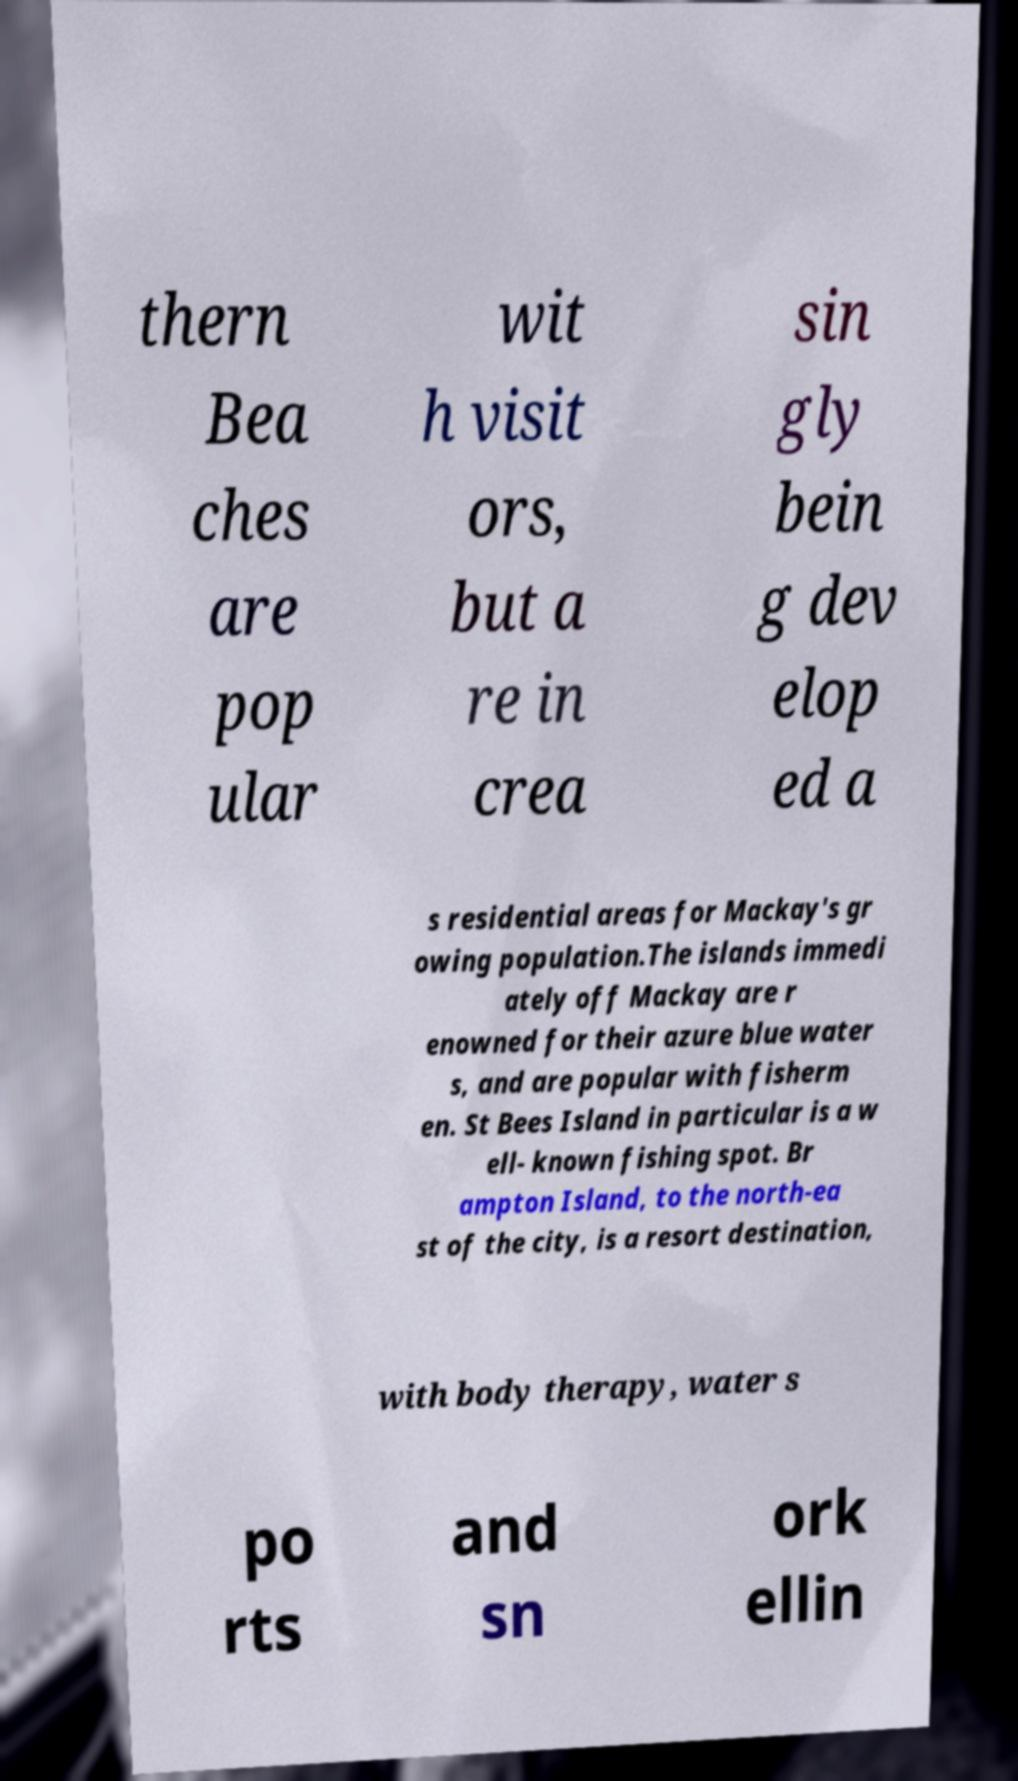For documentation purposes, I need the text within this image transcribed. Could you provide that? thern Bea ches are pop ular wit h visit ors, but a re in crea sin gly bein g dev elop ed a s residential areas for Mackay's gr owing population.The islands immedi ately off Mackay are r enowned for their azure blue water s, and are popular with fisherm en. St Bees Island in particular is a w ell- known fishing spot. Br ampton Island, to the north-ea st of the city, is a resort destination, with body therapy, water s po rts and sn ork ellin 